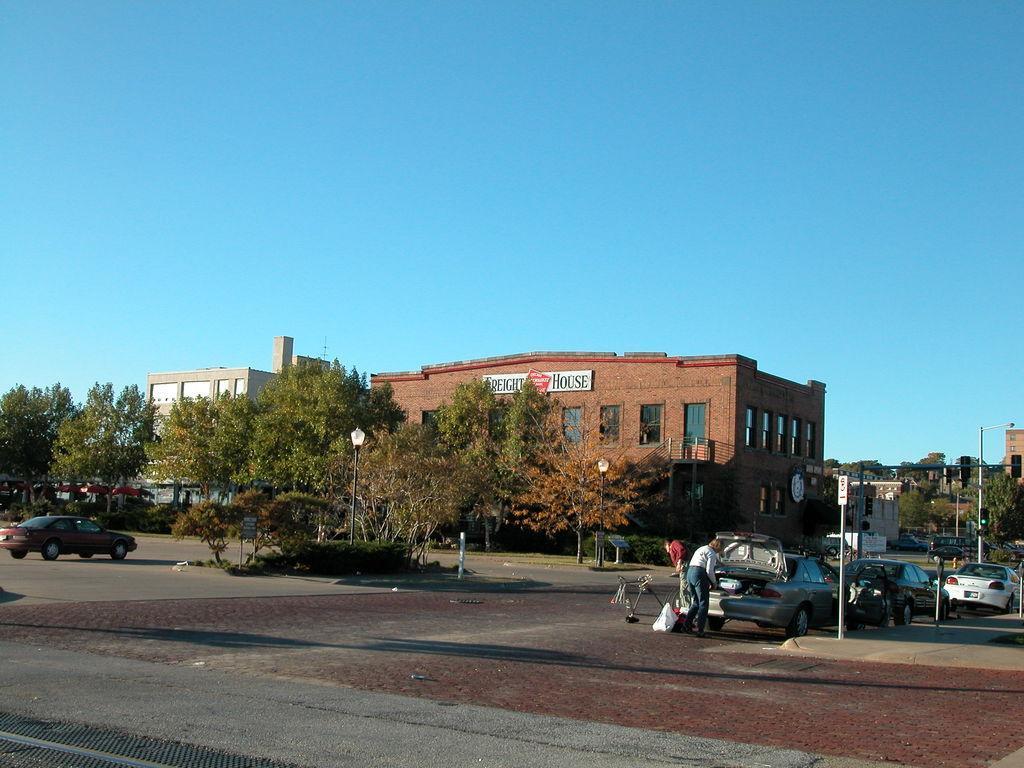In one or two sentences, can you explain what this image depicts? In the image we can see there are many vehicles and trees. We can see there are even people wearing clothes. Here we can see the poles, buildings and windows of the buildings. Here we can see the road and the sky. 